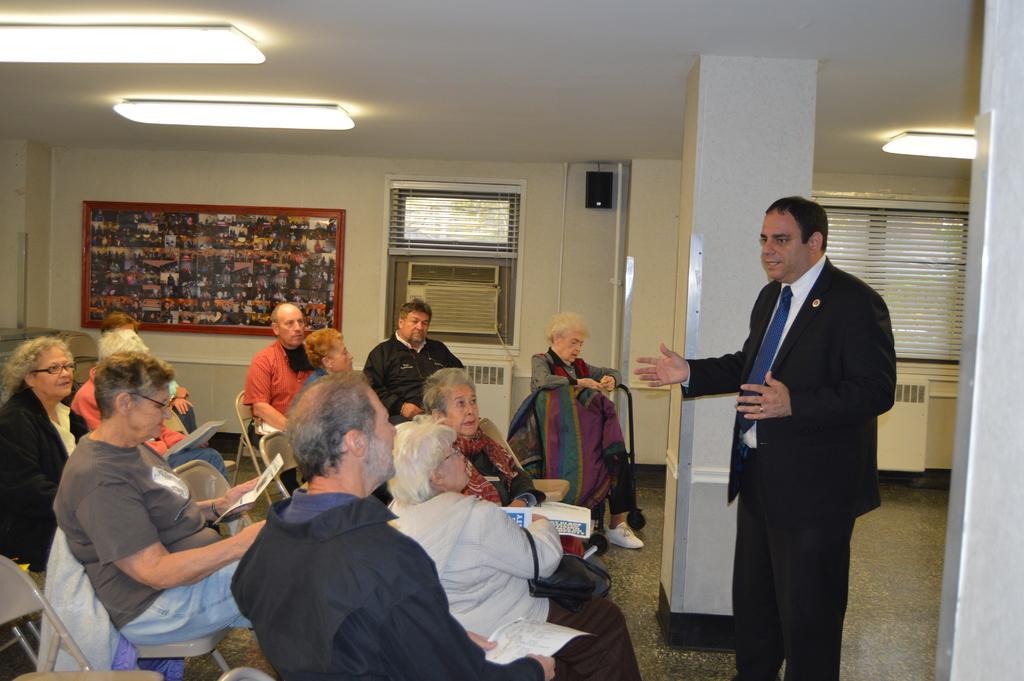Can you describe this image briefly? In this image we can see a group of people wearing dress are sitting on chairs in placed on the floor. One person wearing a coat and tie is standing on the floor. In the background, we can see windows, air conditioner, photo frame on the wall, a group of lights and a speaker. 